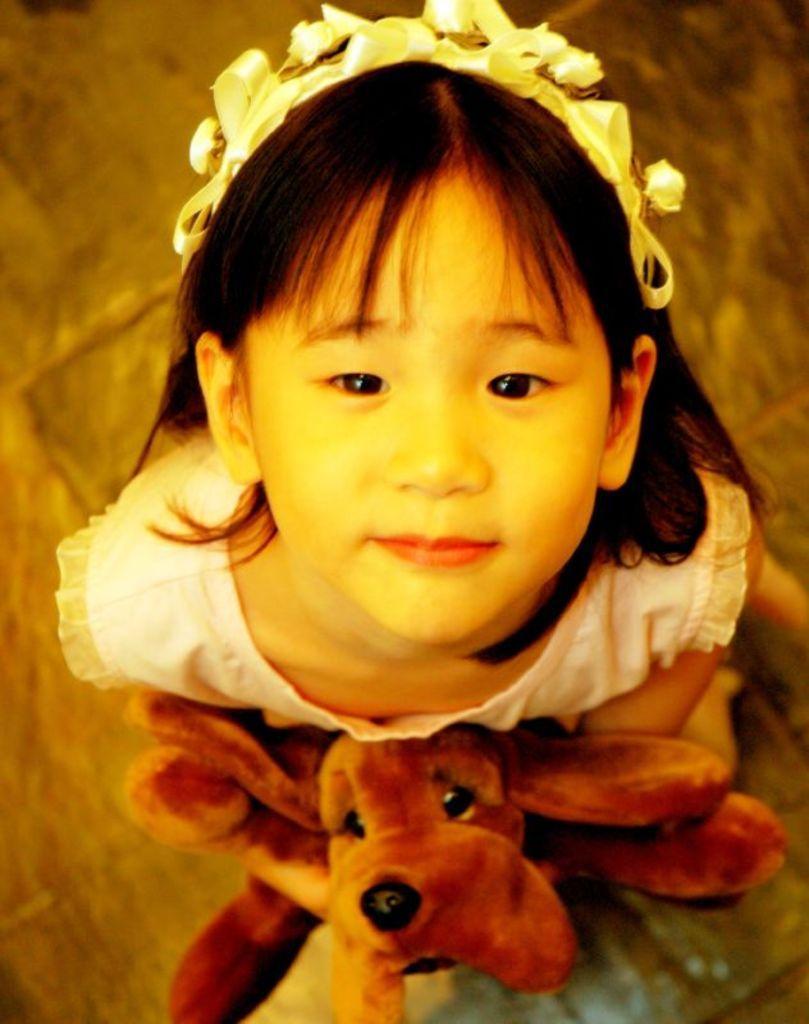Could you give a brief overview of what you see in this image? The kid is holding a dog toy in her hands and looking upwards. 